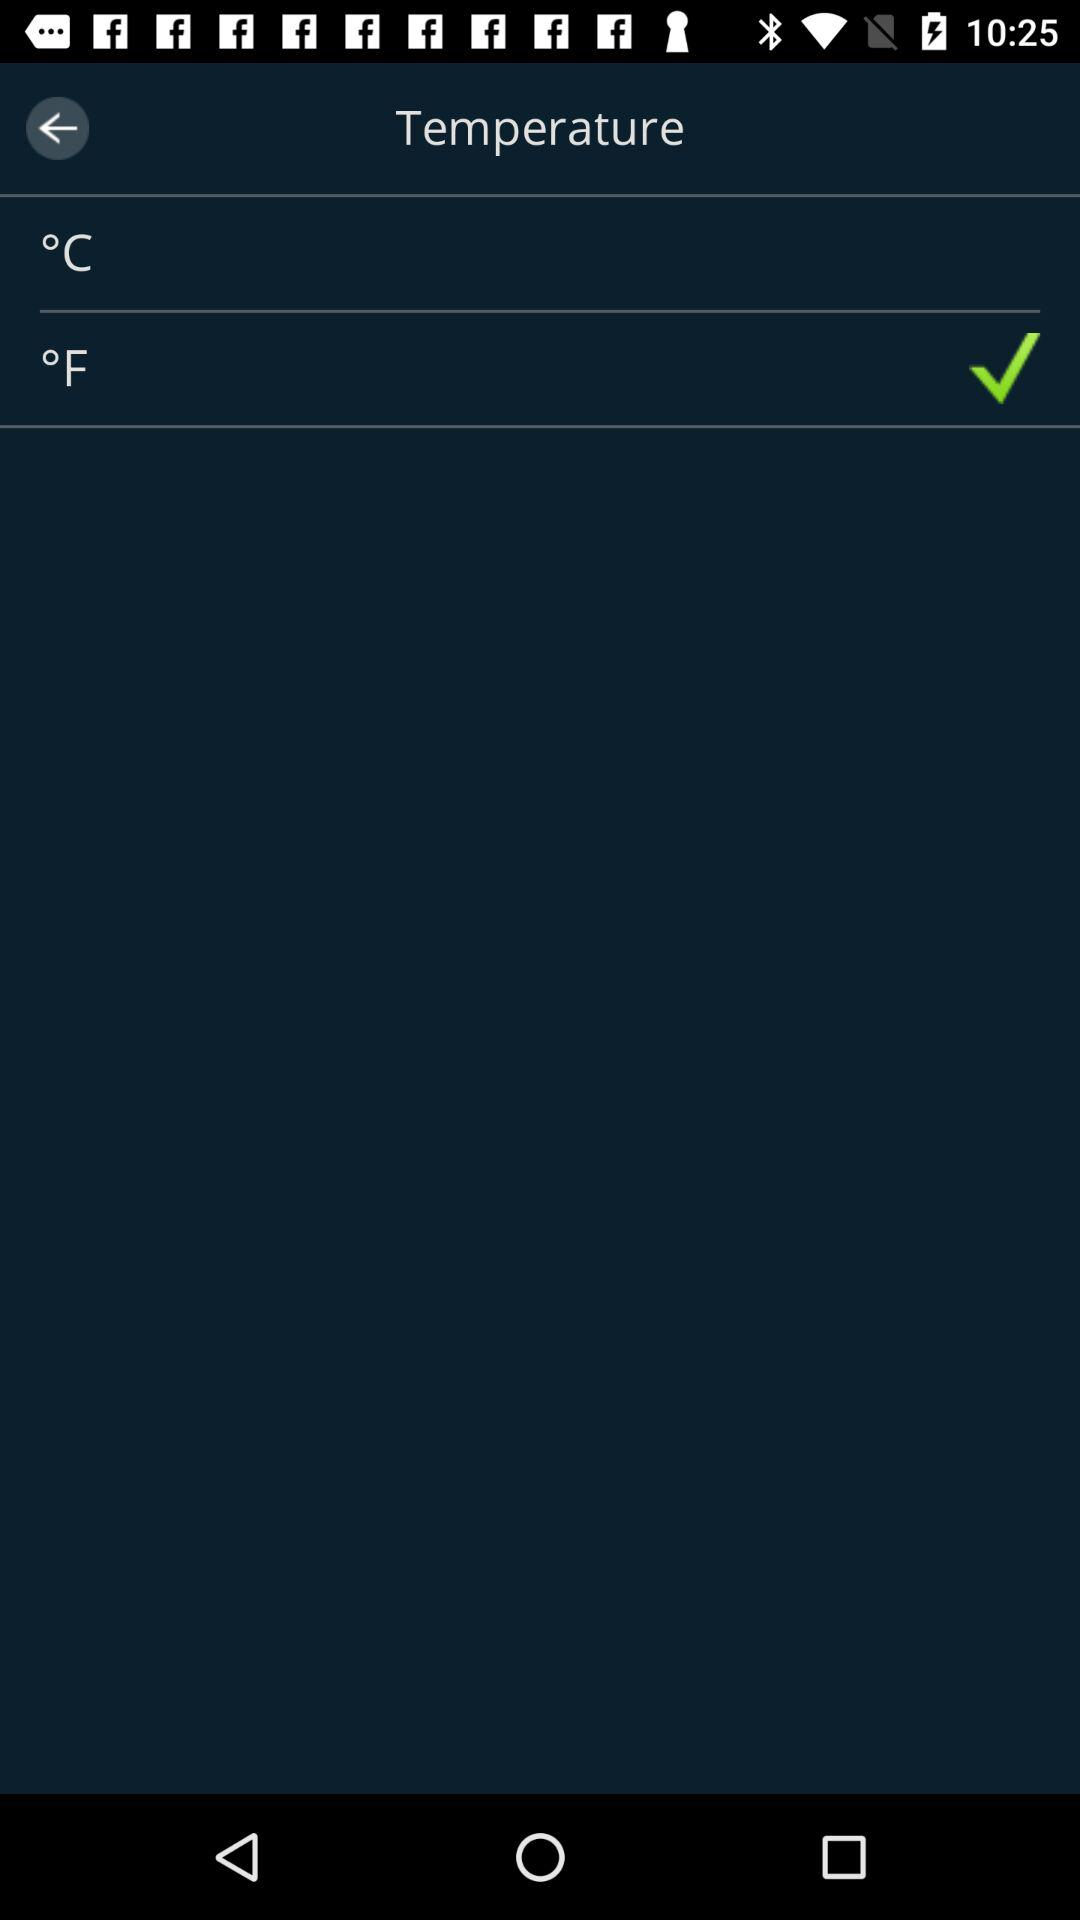What is the selected unit for measuring temperature? The selected unit for measuring temperature is "°F". 